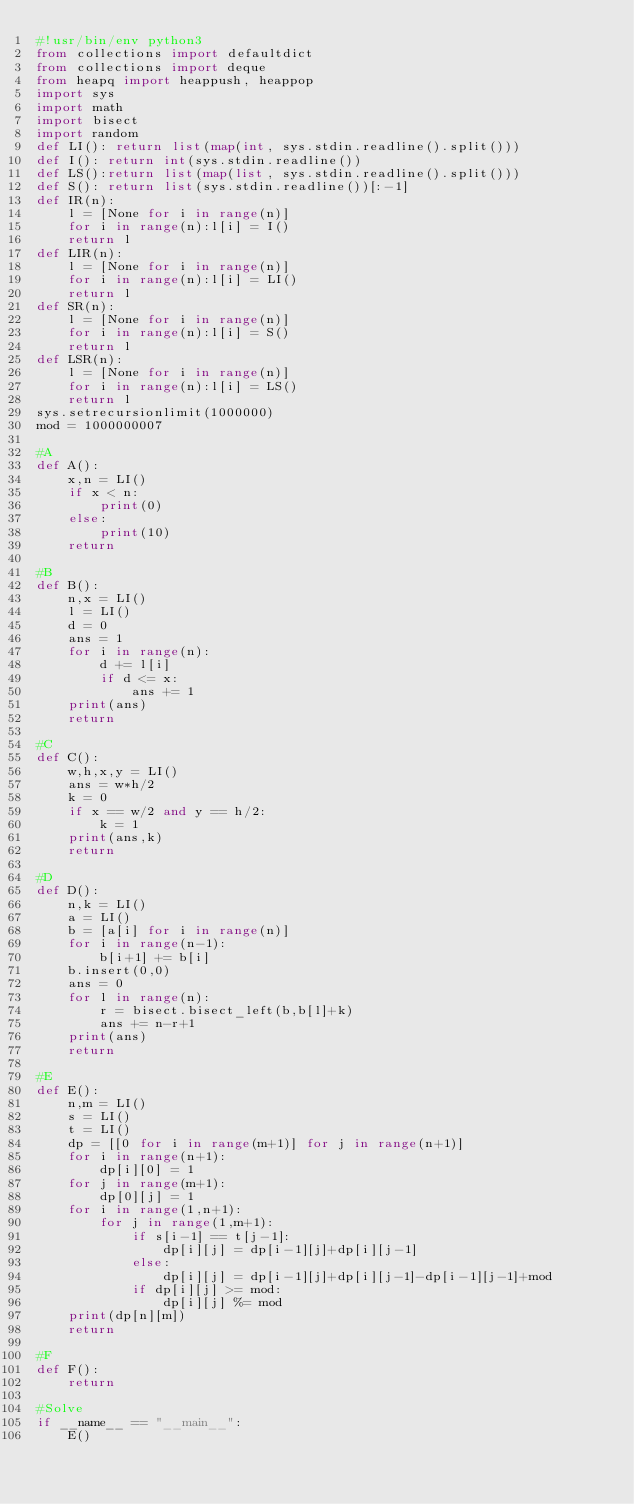<code> <loc_0><loc_0><loc_500><loc_500><_Python_>#!usr/bin/env python3
from collections import defaultdict
from collections import deque
from heapq import heappush, heappop
import sys
import math
import bisect
import random
def LI(): return list(map(int, sys.stdin.readline().split()))
def I(): return int(sys.stdin.readline())
def LS():return list(map(list, sys.stdin.readline().split()))
def S(): return list(sys.stdin.readline())[:-1]
def IR(n):
    l = [None for i in range(n)]
    for i in range(n):l[i] = I()
    return l
def LIR(n):
    l = [None for i in range(n)]
    for i in range(n):l[i] = LI()
    return l
def SR(n):
    l = [None for i in range(n)]
    for i in range(n):l[i] = S()
    return l
def LSR(n):
    l = [None for i in range(n)]
    for i in range(n):l[i] = LS()
    return l
sys.setrecursionlimit(1000000)
mod = 1000000007

#A
def A():
    x,n = LI()
    if x < n:
        print(0)
    else:
        print(10)
    return

#B
def B():
    n,x = LI()
    l = LI()
    d = 0
    ans = 1
    for i in range(n):
        d += l[i]
        if d <= x:
            ans += 1
    print(ans)
    return

#C
def C():
    w,h,x,y = LI()
    ans = w*h/2
    k = 0
    if x == w/2 and y == h/2:
        k = 1
    print(ans,k)
    return

#D
def D():
    n,k = LI()
    a = LI()
    b = [a[i] for i in range(n)]
    for i in range(n-1):
        b[i+1] += b[i]
    b.insert(0,0)
    ans = 0
    for l in range(n):
        r = bisect.bisect_left(b,b[l]+k)
        ans += n-r+1
    print(ans)
    return

#E
def E():
    n,m = LI()
    s = LI()
    t = LI()
    dp = [[0 for i in range(m+1)] for j in range(n+1)]
    for i in range(n+1):
        dp[i][0] = 1
    for j in range(m+1):
        dp[0][j] = 1
    for i in range(1,n+1):
        for j in range(1,m+1):
            if s[i-1] == t[j-1]:
                dp[i][j] = dp[i-1][j]+dp[i][j-1]
            else:
                dp[i][j] = dp[i-1][j]+dp[i][j-1]-dp[i-1][j-1]+mod
            if dp[i][j] >= mod:
                dp[i][j] %= mod
    print(dp[n][m])
    return

#F
def F():
    return

#Solve
if __name__ == "__main__":
    E()
</code> 